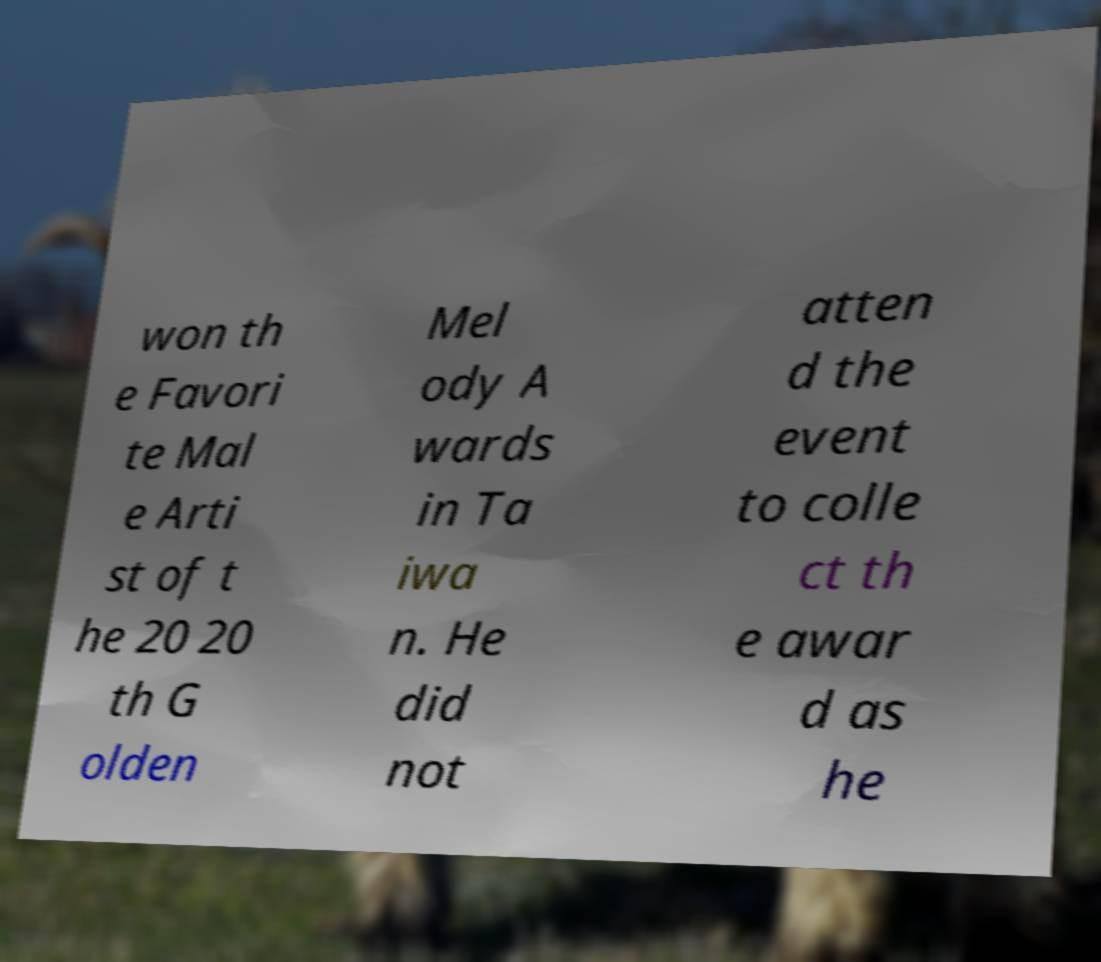Please identify and transcribe the text found in this image. won th e Favori te Mal e Arti st of t he 20 20 th G olden Mel ody A wards in Ta iwa n. He did not atten d the event to colle ct th e awar d as he 